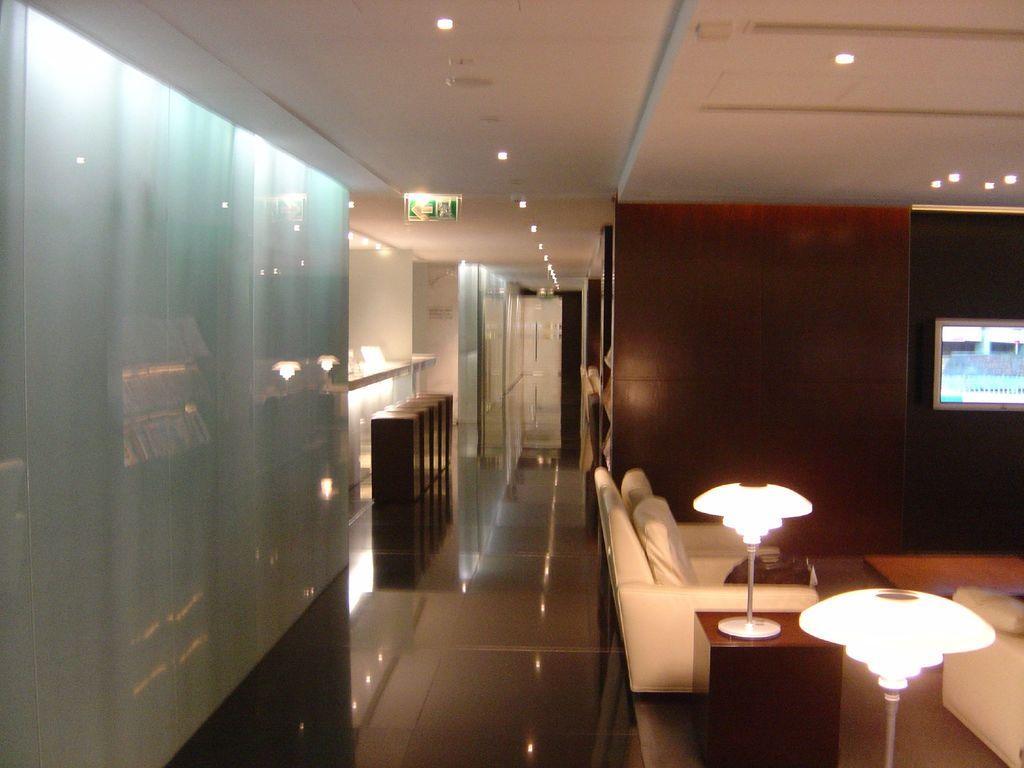Describe this image in one or two sentences. In this image we can see chairs, table beside the chair and a lamp on the table, lights attached to the roof and wooden objects and a TV attached to the wall. 